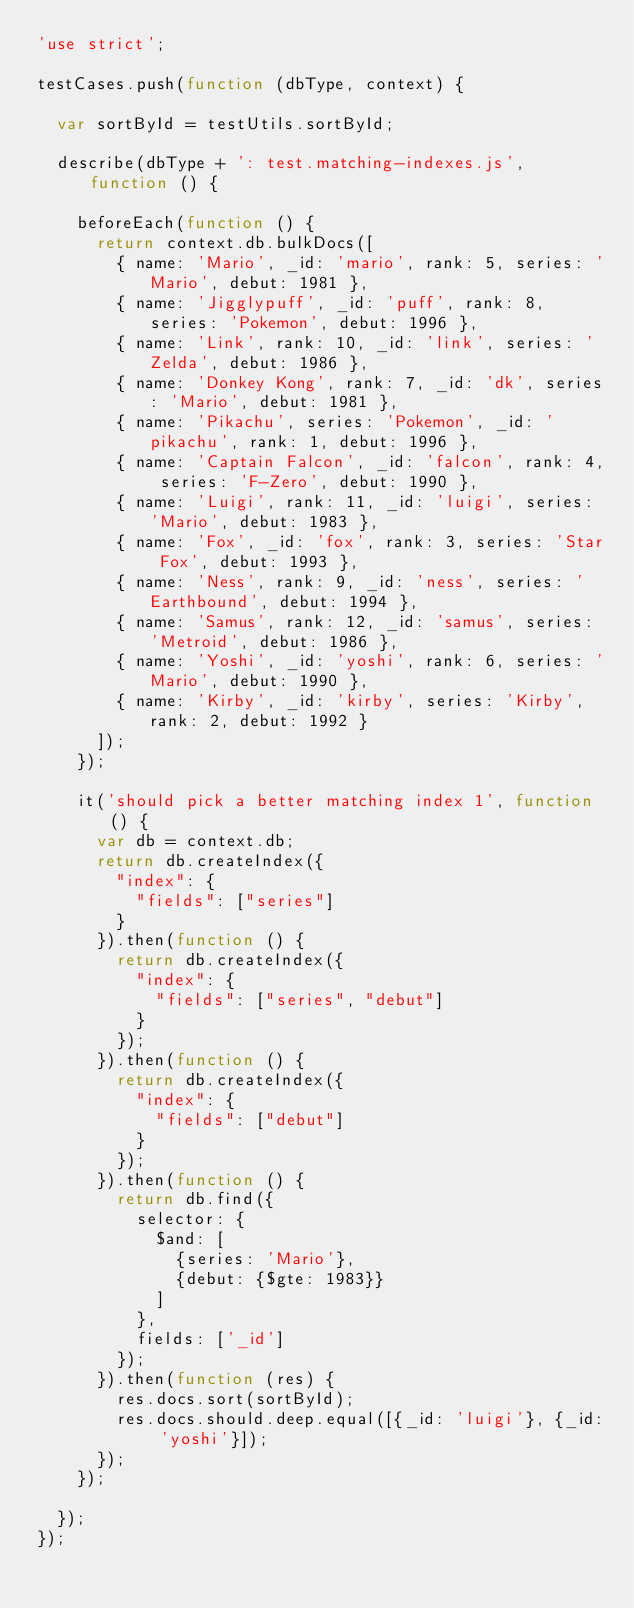Convert code to text. <code><loc_0><loc_0><loc_500><loc_500><_JavaScript_>'use strict';

testCases.push(function (dbType, context) {

  var sortById = testUtils.sortById;

  describe(dbType + ': test.matching-indexes.js', function () {

    beforeEach(function () {
      return context.db.bulkDocs([
        { name: 'Mario', _id: 'mario', rank: 5, series: 'Mario', debut: 1981 },
        { name: 'Jigglypuff', _id: 'puff', rank: 8, series: 'Pokemon', debut: 1996 },
        { name: 'Link', rank: 10, _id: 'link', series: 'Zelda', debut: 1986 },
        { name: 'Donkey Kong', rank: 7, _id: 'dk', series: 'Mario', debut: 1981 },
        { name: 'Pikachu', series: 'Pokemon', _id: 'pikachu', rank: 1, debut: 1996 },
        { name: 'Captain Falcon', _id: 'falcon', rank: 4, series: 'F-Zero', debut: 1990 },
        { name: 'Luigi', rank: 11, _id: 'luigi', series: 'Mario', debut: 1983 },
        { name: 'Fox', _id: 'fox', rank: 3, series: 'Star Fox', debut: 1993 },
        { name: 'Ness', rank: 9, _id: 'ness', series: 'Earthbound', debut: 1994 },
        { name: 'Samus', rank: 12, _id: 'samus', series: 'Metroid', debut: 1986 },
        { name: 'Yoshi', _id: 'yoshi', rank: 6, series: 'Mario', debut: 1990 },
        { name: 'Kirby', _id: 'kirby', series: 'Kirby', rank: 2, debut: 1992 }
      ]);
    });

    it('should pick a better matching index 1', function () {
      var db = context.db;
      return db.createIndex({
        "index": {
          "fields": ["series"]
        }
      }).then(function () {
        return db.createIndex({
          "index": {
            "fields": ["series", "debut"]
          }
        });
      }).then(function () {
        return db.createIndex({
          "index": {
            "fields": ["debut"]
          }
        });
      }).then(function () {
        return db.find({
          selector: {
            $and: [
              {series: 'Mario'},
              {debut: {$gte: 1983}}
            ]
          },
          fields: ['_id']
        });
      }).then(function (res) {
        res.docs.sort(sortById);
        res.docs.should.deep.equal([{_id: 'luigi'}, {_id: 'yoshi'}]);
      });
    });

  });
});</code> 